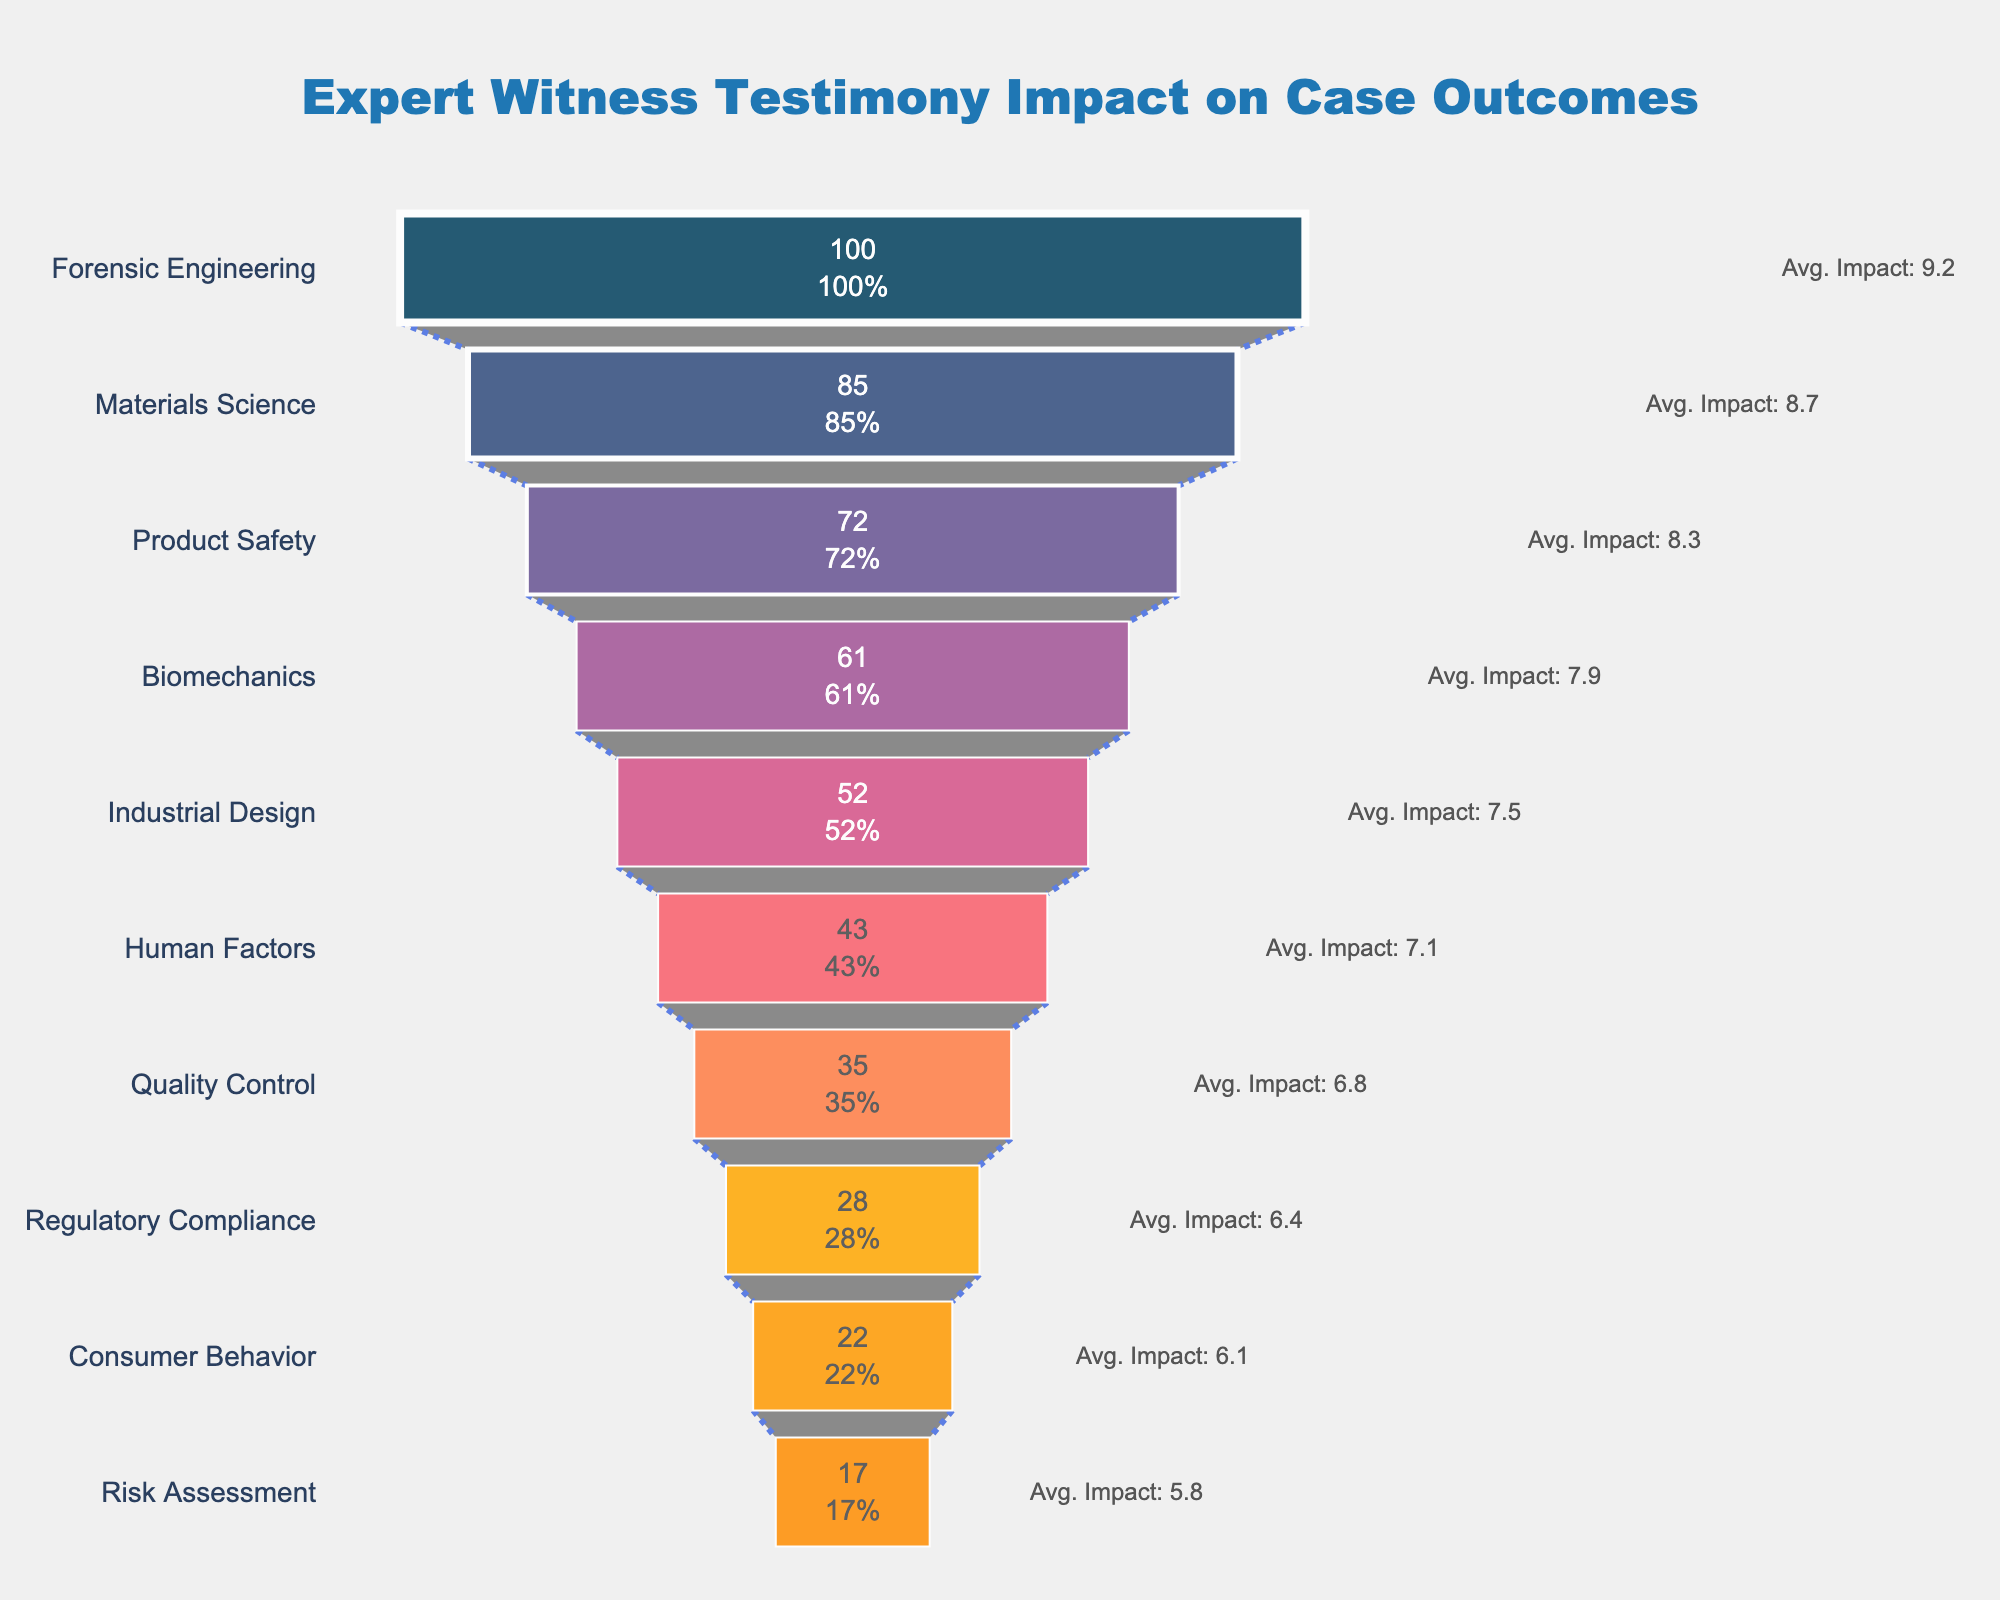Which expertise area influences the most cases? The figure shows the "Cases Influenced" by different expertise areas; the top of the funnel represents the area influencing the most cases. In this case, it is Forensic Engineering, with 100 cases influenced.
Answer: Forensic Engineering How many expertise areas are displayed in the figure? By counting the distinct segments in the funnel chart, we see there are 10 different expertise areas displayed.
Answer: 10 Which expertise areas have an average impact score greater than 8? Observing the annotations next to each expertise area in the funnel chart, we see that Forensic Engineering, Materials Science, and Product Safety all have average impact scores greater than 8.
Answer: Forensic Engineering, Materials Science, Product Safety What is the total number of cases influenced by all expertise areas combined? To find the total number of cases influenced, we sum the "Cases Influenced" for all expertise areas: 100 + 85 + 72 + 61 + 52 + 43 + 35 + 28 + 22 + 17 = 515
Answer: 515 Compare the average impact score of Human Factors and Industrial Design. Which one is higher? Comparing the annotated average impact scores, Human Factors has an average impact score of 7.1, while Industrial Design has a score of 7.5. Thus, Industrial Design is higher.
Answer: Industrial Design What percentage of the total cases influenced is attributable to Product Safety expertise? First, find the number of cases influenced by Product Safety, which is 72. Then, divide this by the total cases (515) and multiply by 100 to get the percentage: (72 / 515) * 100 ≈ 13.98%
Answer: ~13.98% Which expertise area has the lowest average impact score? From the annotations in the funnel chart, Risk Assessment has the lowest average impact score, which is 5.8.
Answer: Risk Assessment What is the average of all the "Average Impact Scores" displayed? Adding all the average impact scores: 9.2 + 8.7 + 8.3 + 7.9 + 7.5 + 7.1 + 6.8 + 6.4 + 6.1 + 5.8 = 73.8. Then, dividing by 10 (number of expertise areas): 73.8 / 10 = 7.38
Answer: 7.38 How many more cases does Forensic Engineering influence compared to Consumer Behavior? Forensic Engineering influences 100 cases, while Consumer Behavior influences 22 cases. The difference is 100 - 22 = 78
Answer: 78 